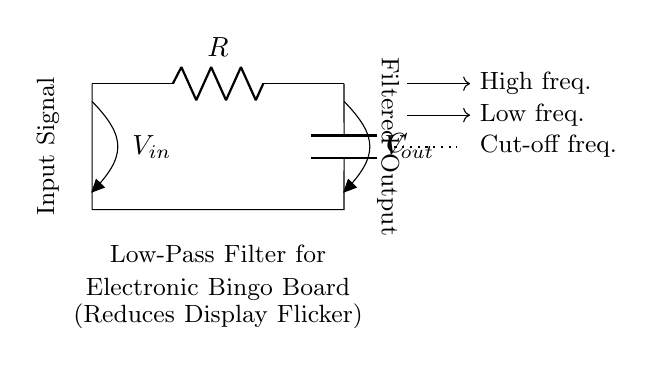What are the components in this circuit? The circuit consists of a resistor and a capacitor, which are necessary for forming a low-pass filter. The resistor is labeled R and the capacitor is labeled C in the diagram.
Answer: Resistor and capacitor What is the purpose of this low-pass filter? The low-pass filter is designed to reduce display flicker by allowing low-frequency signals to pass while attenuating higher-frequency signals, resulting in a smoother output.
Answer: Reduce display flicker What is the voltage at the input? The voltage at the input is denoted as V-in in the circuit diagram, indicating the point where the unfiltered signal enters the filter. The exact value of V-in isn't shown here.
Answer: V-in What does the dotted line in the circuit signify? The dotted line represents the cut-off frequency where the transition occurs from passing low frequencies to attenuating high frequencies, emphasizing the functional point of the filter.
Answer: Cut-off frequency How does the filter affect high-frequency signals? The filter attenuates high-frequency signals, meaning these signals are reduced or diminished in strength as they pass through the circuit. This behavior is characteristic of low-pass filters.
Answer: Attenuates high frequencies What is the configuration of this filter? The filter is configured in a series arrangement where the resistor and capacitor are connected in a way that allows for voltage division, which is essential for its filtering function.
Answer: Series configuration 